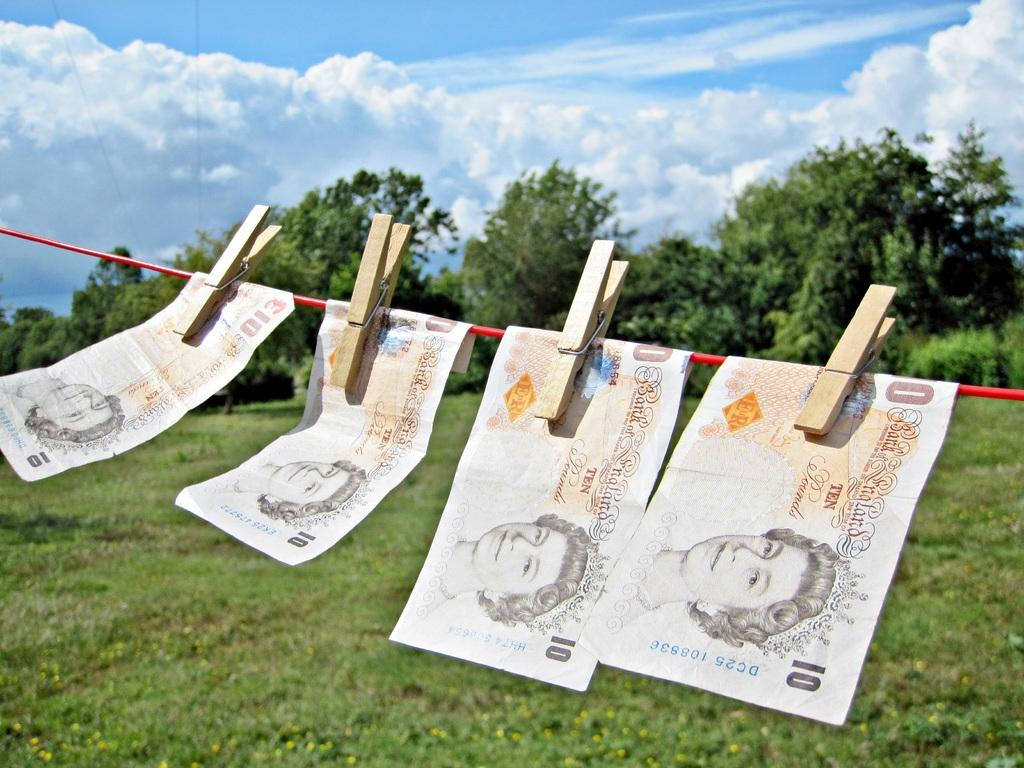<image>
Render a clear and concise summary of the photo. a few pieces of paper with the number 10 on them 